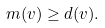<formula> <loc_0><loc_0><loc_500><loc_500>m ( v ) \geq d ( v ) .</formula> 